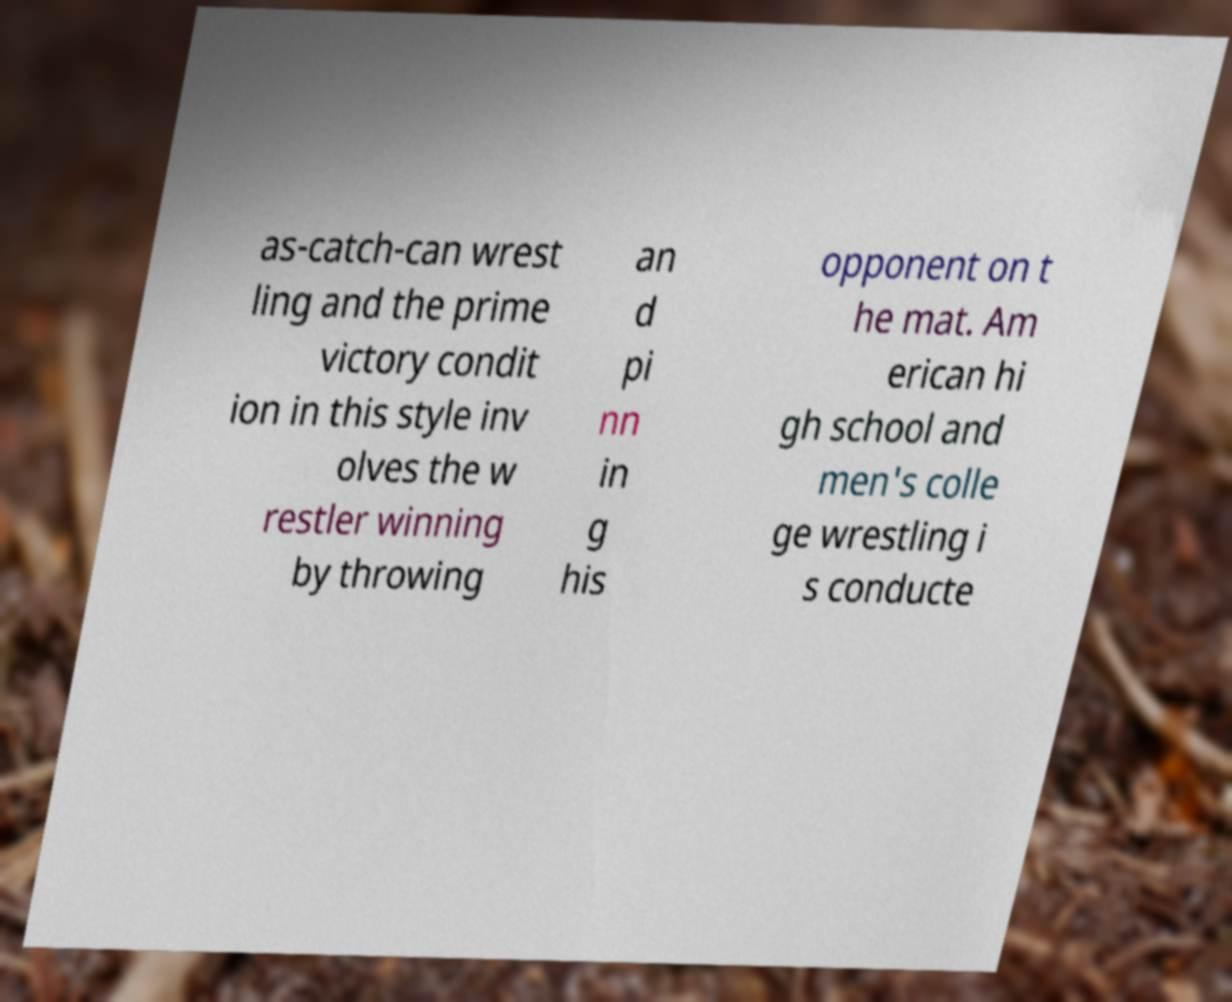Please identify and transcribe the text found in this image. as-catch-can wrest ling and the prime victory condit ion in this style inv olves the w restler winning by throwing an d pi nn in g his opponent on t he mat. Am erican hi gh school and men's colle ge wrestling i s conducte 